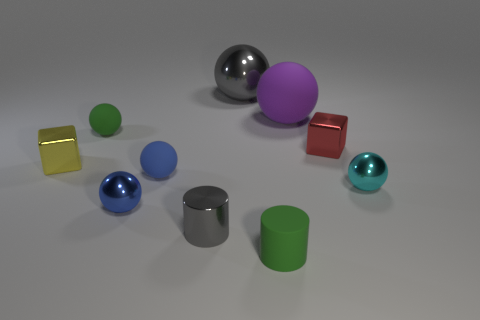There is a gray object behind the small yellow object; does it have the same shape as the tiny cyan metallic object in front of the large matte sphere?
Your response must be concise. Yes. What shape is the cyan thing that is the same size as the blue matte ball?
Provide a short and direct response. Sphere. Is the number of big matte things that are in front of the purple matte object the same as the number of small shiny spheres behind the small yellow cube?
Make the answer very short. Yes. Is there any other thing that is the same shape as the tiny blue rubber thing?
Make the answer very short. Yes. Is the gray object in front of the red block made of the same material as the small green cylinder?
Your response must be concise. No. There is a yellow cube that is the same size as the red metal thing; what is its material?
Your answer should be compact. Metal. How many other objects are there of the same material as the big purple sphere?
Make the answer very short. 3. There is a green matte cylinder; does it have the same size as the green thing that is on the left side of the gray sphere?
Offer a terse response. Yes. Are there fewer yellow cubes that are to the right of the small gray shiny thing than metal cubes that are in front of the red metallic cube?
Provide a short and direct response. Yes. What size is the metallic cube that is to the left of the shiny cylinder?
Your answer should be compact. Small. 